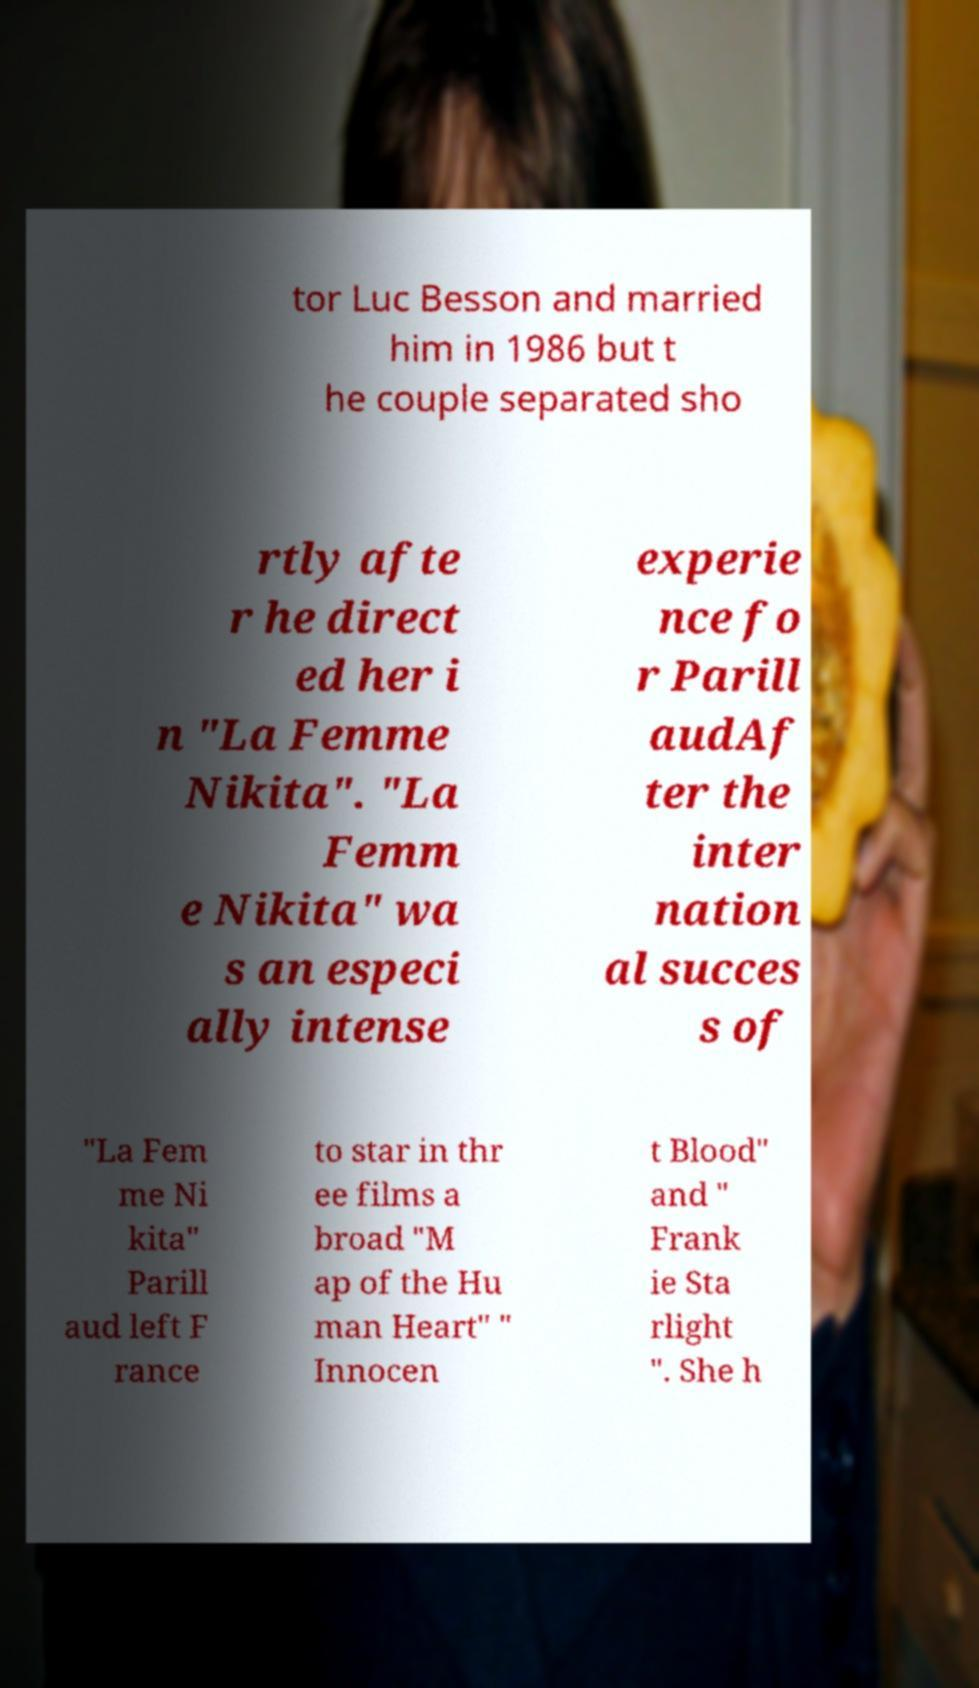I need the written content from this picture converted into text. Can you do that? tor Luc Besson and married him in 1986 but t he couple separated sho rtly afte r he direct ed her i n "La Femme Nikita". "La Femm e Nikita" wa s an especi ally intense experie nce fo r Parill audAf ter the inter nation al succes s of "La Fem me Ni kita" Parill aud left F rance to star in thr ee films a broad "M ap of the Hu man Heart" " Innocen t Blood" and " Frank ie Sta rlight ". She h 